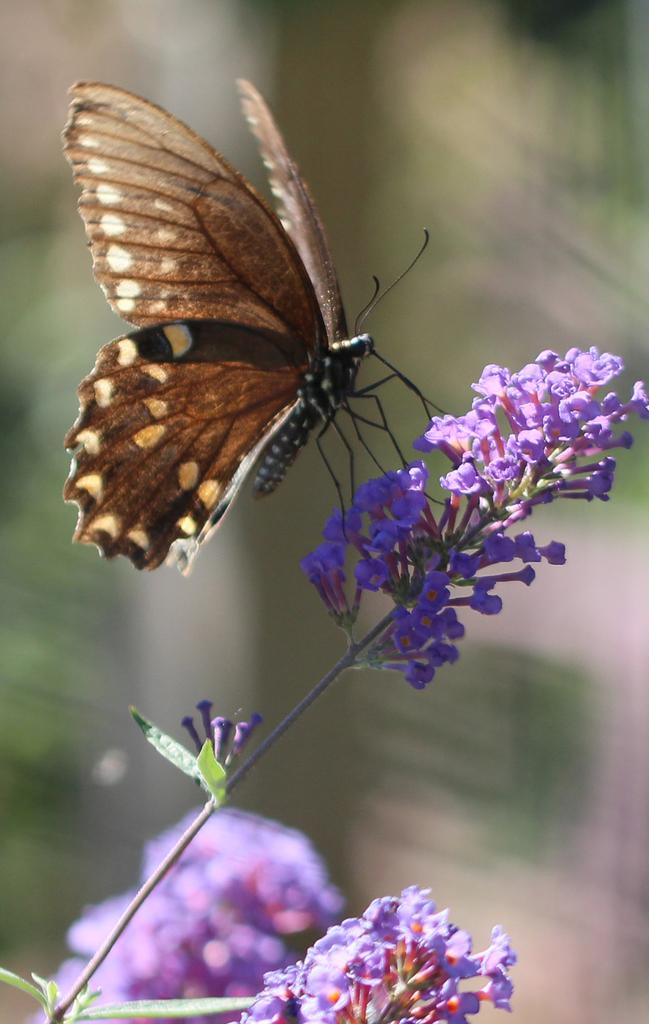What type of animal can be seen in the image? There is a butterfly in the image. What other living organisms are present in the image? There are flowers in the image. Can you describe the stem in the image? Yes, there is a stem in the image. Where are the flowers located in the image? Flowers are present at the bottom of the image. How would you describe the background of the image? The background of the image is blurred. What type of drug is being discussed in the meeting in the image? There is no meeting or drug present in the image; it features a butterfly and flowers. What shape is the butterfly in the image? The shape of the butterfly cannot be determined from the image alone, as it is a 2D representation. 